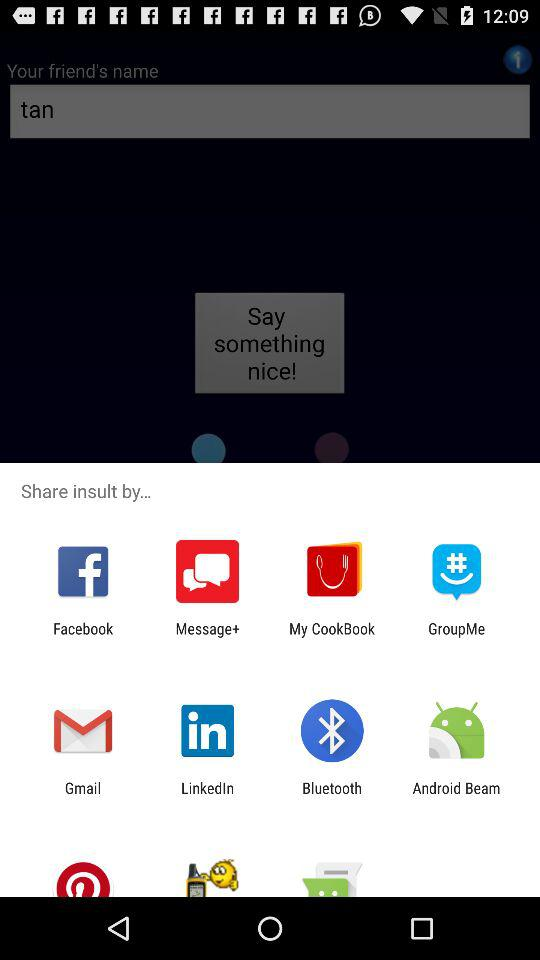What are the different applications available to share "insult by..."? The different applications available to share "insult by..." are "Facebook", "Message+", "My CookBook", "GroupMe", "Gmail", "LinkedIn", "Bluetooth" and "Android Beam". 